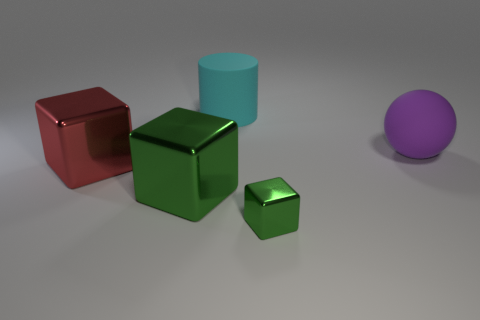Is the material of the big thing that is behind the large ball the same as the red object?
Offer a terse response. No. What is the shape of the red object?
Offer a very short reply. Cube. What number of brown things are blocks or cylinders?
Ensure brevity in your answer.  0. What number of other things are made of the same material as the red thing?
Offer a terse response. 2. There is a green metal object that is right of the big cylinder; is it the same shape as the big cyan matte object?
Your response must be concise. No. Are there any green cubes?
Your answer should be compact. Yes. Is there anything else that is the same shape as the red metal object?
Your answer should be very brief. Yes. Are there more big rubber cylinders behind the big cyan cylinder than small yellow matte balls?
Make the answer very short. No. There is a big sphere; are there any small blocks to the right of it?
Make the answer very short. No. Do the cyan cylinder and the rubber ball have the same size?
Provide a short and direct response. Yes. 